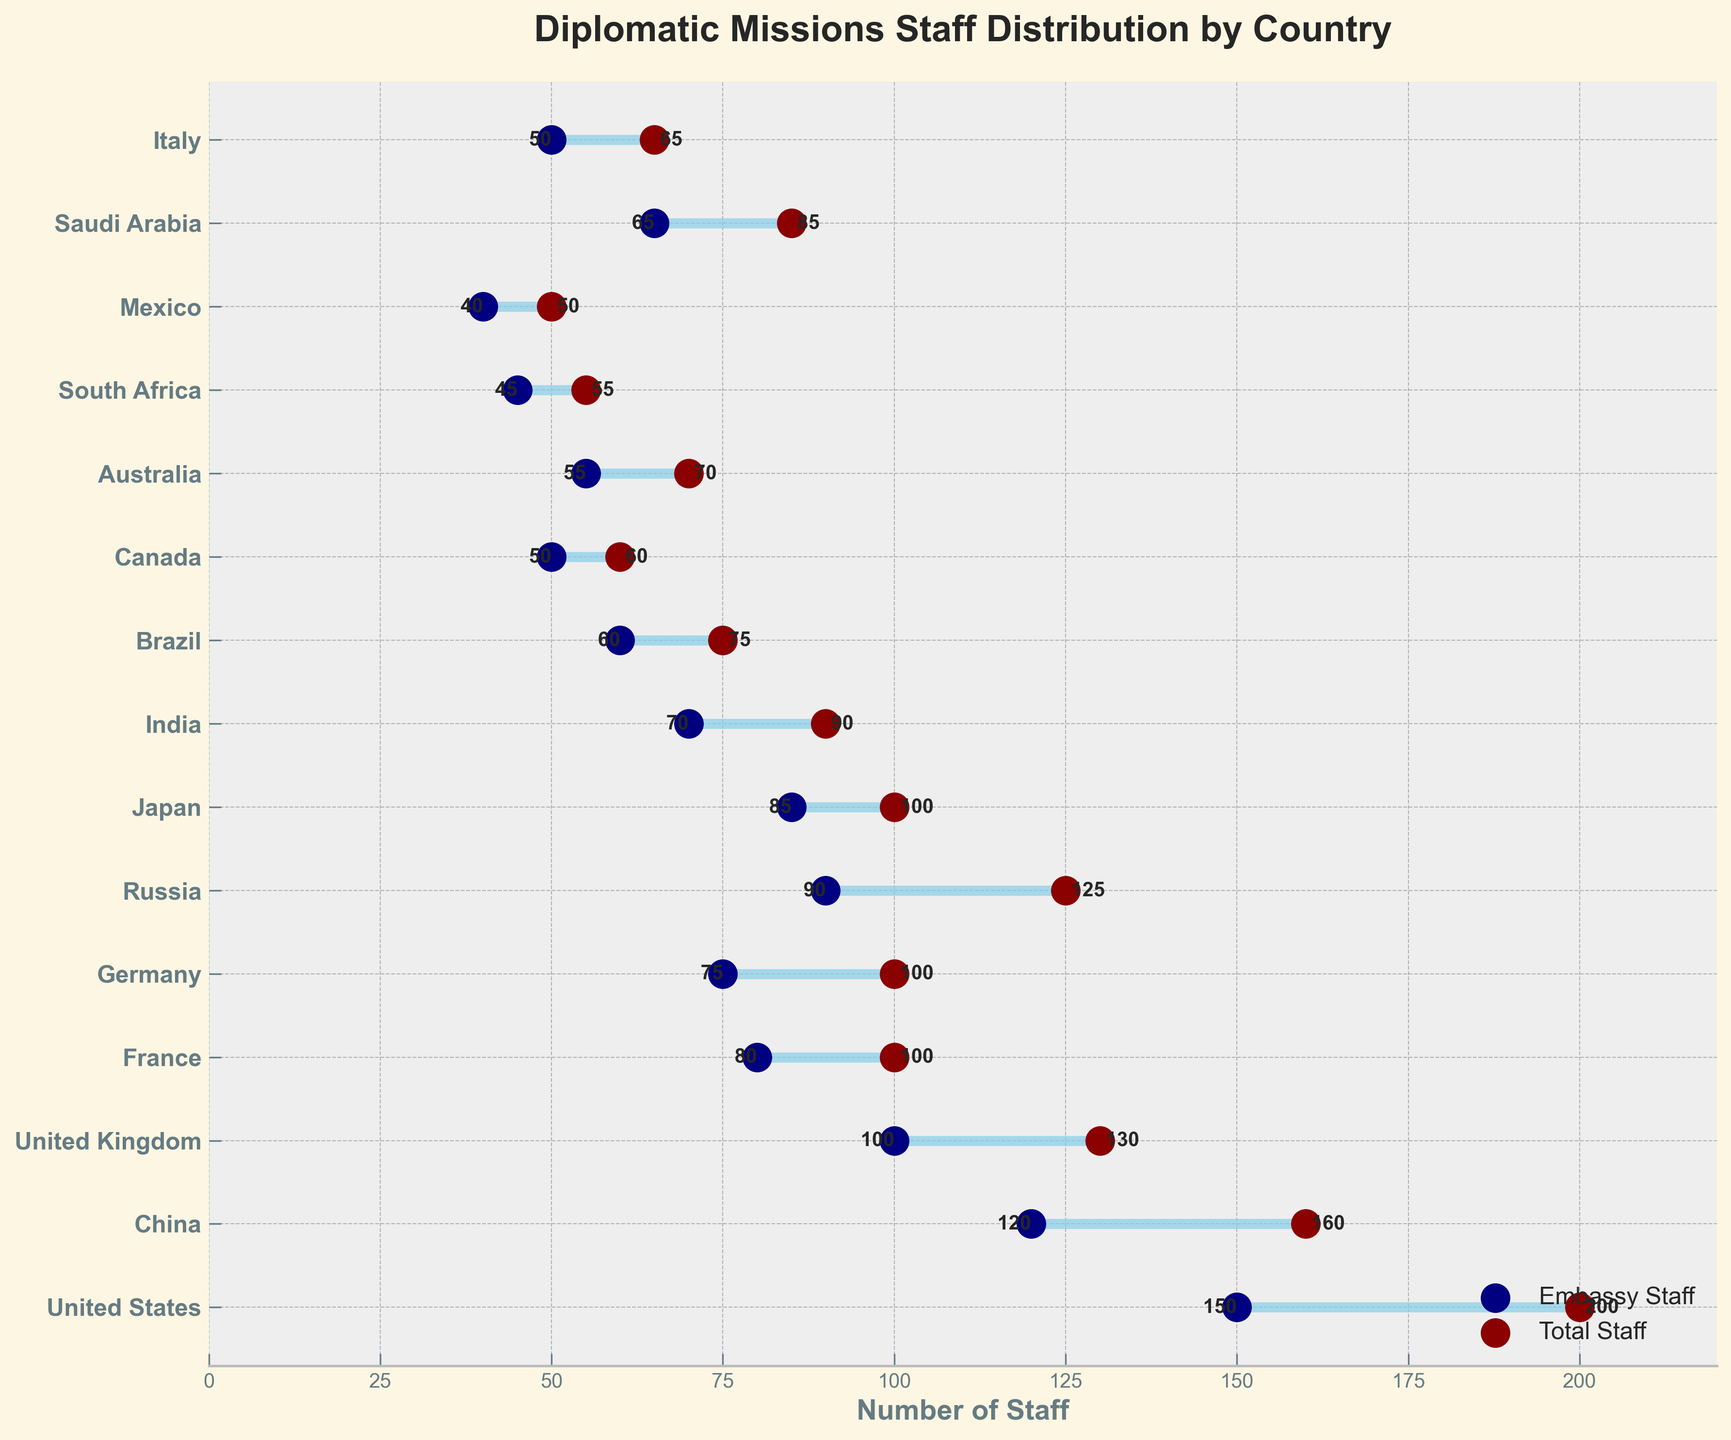How many staff members does the United States have in total? The title and the data clearly indicate each country's total staff numbers. For the United States, the total staff is represented by a dark red dot aligned with the label "United States." The number next to it shows 200.
Answer: 200 What is the range of staff numbers for Russia? The range is visually represented by the horizontal line between the embassy staff (navy dot) and the total staff (dark red dot) numbers for Russia. Russia has 90 embassy staff and 125 total staff. The difference between these numbers is 125 - 90.
Answer: 35 Which country has the second-highest total staff? By comparing the dark red dots for all countries, the highest total staff is the United States (200), and the second highest is China (160). This is visually straightforward by observing the next longest horizontal line and the positioning of the dark red dots.
Answer: China What is the average number of embassy staff for countries with 100 total staff? First identify the countries with 100 total staff: France, Germany, and Japan. Their embassy staff numbers are 80, 75, and 85, respectively. The average is calculated as (80 + 75 + 85) / 3.
Answer: 80 Among Brazil and Australia, which country has more consulate staff? Brazil has a consulate staff of 15, and Australia also has 15. This can be seen by comparing the labels and values of the consulate staff (navy dots) for each country.
Answer: They are equal Which country has the largest gap between embassy staff and total staff? Analyze the gaps represented by the horizontal line lengths between the navy and dark red dots. The United States has the largest gap, with embassy staff at 150 and total staff at 200, resulting in a gap of 50.
Answer: United States In which range does Saudi Arabia fall in embassy staff distribution? Saudi Arabia's embassy staff is 65. Review the embassy staff numbers and identify that Saudi Arabia falls in the range between 60 and 70.
Answer: 60-70 How many countries have fewer than 75 embassy staff? Count the number of countries with embassy staff less than 75 by observing the navy dots’ numbers: India (70), Brazil (60), Canada (50), South Africa (45), Mexico (40), Saudi Arabia (65), and Italy (50). This totals 7 countries.
Answer: 7 What is the combined total staff of Germany and France? Germany and France both have 100 total staff each, as indicated by the dark red dots next to their country labels. The combined total is the sum of the two, 100 + 100.
Answer: 200 